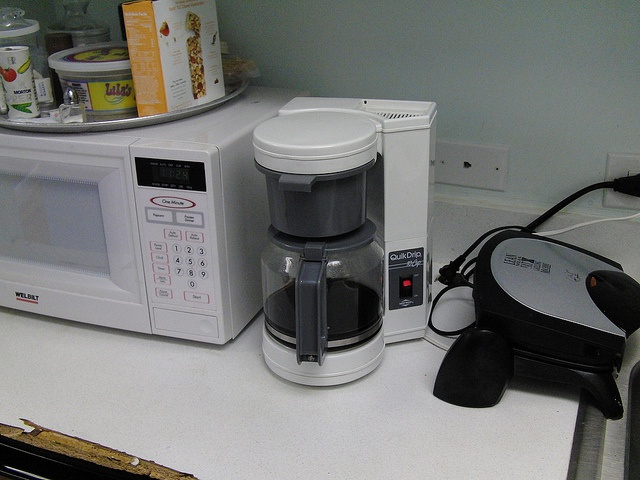Describe the objects in this image and their specific colors. I can see a microwave in darkgreen, darkgray, gray, and black tones in this image. 